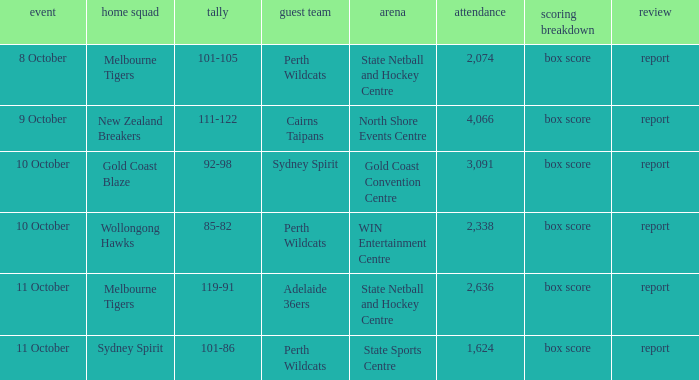What was the crowd size for the game with a score of 101-105? 2074.0. 